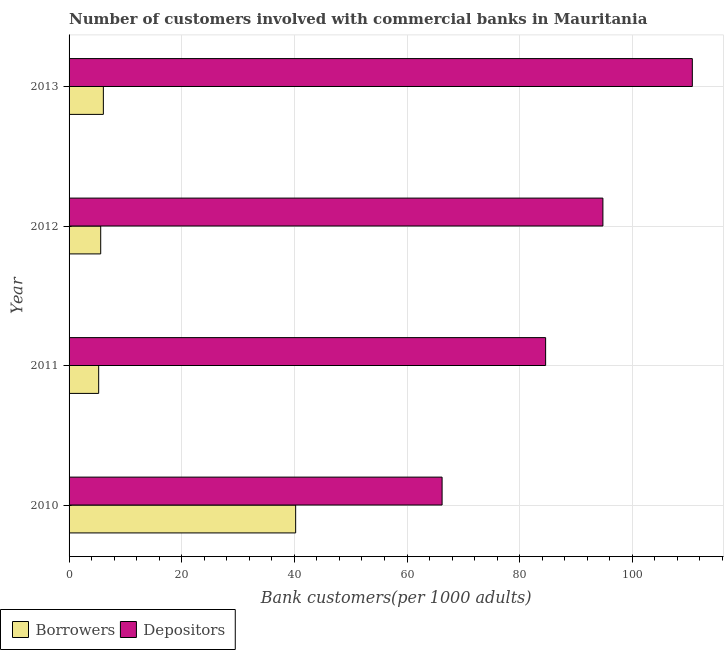Are the number of bars per tick equal to the number of legend labels?
Your answer should be very brief. Yes. Are the number of bars on each tick of the Y-axis equal?
Give a very brief answer. Yes. How many bars are there on the 4th tick from the top?
Make the answer very short. 2. What is the number of depositors in 2011?
Your answer should be compact. 84.61. Across all years, what is the maximum number of borrowers?
Provide a short and direct response. 40.23. Across all years, what is the minimum number of borrowers?
Make the answer very short. 5.26. What is the total number of borrowers in the graph?
Keep it short and to the point. 57.19. What is the difference between the number of depositors in 2012 and that in 2013?
Provide a succinct answer. -15.88. What is the difference between the number of borrowers in 2012 and the number of depositors in 2013?
Offer a very short reply. -105.04. What is the average number of depositors per year?
Give a very brief answer. 89.07. In the year 2012, what is the difference between the number of depositors and number of borrowers?
Your response must be concise. 89.16. What is the ratio of the number of depositors in 2010 to that in 2012?
Your answer should be compact. 0.7. Is the number of depositors in 2010 less than that in 2012?
Provide a short and direct response. Yes. Is the difference between the number of depositors in 2011 and 2012 greater than the difference between the number of borrowers in 2011 and 2012?
Ensure brevity in your answer.  No. What is the difference between the highest and the second highest number of depositors?
Your response must be concise. 15.88. What is the difference between the highest and the lowest number of depositors?
Keep it short and to the point. 44.43. What does the 2nd bar from the top in 2013 represents?
Make the answer very short. Borrowers. What does the 2nd bar from the bottom in 2010 represents?
Offer a terse response. Depositors. How many bars are there?
Your response must be concise. 8. Are all the bars in the graph horizontal?
Make the answer very short. Yes. Does the graph contain grids?
Ensure brevity in your answer.  Yes. Where does the legend appear in the graph?
Keep it short and to the point. Bottom left. What is the title of the graph?
Your response must be concise. Number of customers involved with commercial banks in Mauritania. What is the label or title of the X-axis?
Offer a terse response. Bank customers(per 1000 adults). What is the Bank customers(per 1000 adults) in Borrowers in 2010?
Provide a short and direct response. 40.23. What is the Bank customers(per 1000 adults) in Depositors in 2010?
Make the answer very short. 66.23. What is the Bank customers(per 1000 adults) of Borrowers in 2011?
Make the answer very short. 5.26. What is the Bank customers(per 1000 adults) of Depositors in 2011?
Provide a short and direct response. 84.61. What is the Bank customers(per 1000 adults) of Borrowers in 2012?
Offer a very short reply. 5.62. What is the Bank customers(per 1000 adults) in Depositors in 2012?
Give a very brief answer. 94.78. What is the Bank customers(per 1000 adults) of Borrowers in 2013?
Provide a succinct answer. 6.09. What is the Bank customers(per 1000 adults) in Depositors in 2013?
Your answer should be compact. 110.66. Across all years, what is the maximum Bank customers(per 1000 adults) in Borrowers?
Your response must be concise. 40.23. Across all years, what is the maximum Bank customers(per 1000 adults) in Depositors?
Keep it short and to the point. 110.66. Across all years, what is the minimum Bank customers(per 1000 adults) of Borrowers?
Provide a short and direct response. 5.26. Across all years, what is the minimum Bank customers(per 1000 adults) in Depositors?
Keep it short and to the point. 66.23. What is the total Bank customers(per 1000 adults) of Borrowers in the graph?
Offer a terse response. 57.19. What is the total Bank customers(per 1000 adults) of Depositors in the graph?
Keep it short and to the point. 356.28. What is the difference between the Bank customers(per 1000 adults) of Borrowers in 2010 and that in 2011?
Your response must be concise. 34.97. What is the difference between the Bank customers(per 1000 adults) of Depositors in 2010 and that in 2011?
Make the answer very short. -18.38. What is the difference between the Bank customers(per 1000 adults) in Borrowers in 2010 and that in 2012?
Provide a succinct answer. 34.61. What is the difference between the Bank customers(per 1000 adults) of Depositors in 2010 and that in 2012?
Provide a short and direct response. -28.55. What is the difference between the Bank customers(per 1000 adults) in Borrowers in 2010 and that in 2013?
Your answer should be compact. 34.14. What is the difference between the Bank customers(per 1000 adults) of Depositors in 2010 and that in 2013?
Your answer should be compact. -44.43. What is the difference between the Bank customers(per 1000 adults) of Borrowers in 2011 and that in 2012?
Ensure brevity in your answer.  -0.36. What is the difference between the Bank customers(per 1000 adults) of Depositors in 2011 and that in 2012?
Keep it short and to the point. -10.17. What is the difference between the Bank customers(per 1000 adults) of Borrowers in 2011 and that in 2013?
Your answer should be compact. -0.83. What is the difference between the Bank customers(per 1000 adults) of Depositors in 2011 and that in 2013?
Ensure brevity in your answer.  -26.05. What is the difference between the Bank customers(per 1000 adults) in Borrowers in 2012 and that in 2013?
Ensure brevity in your answer.  -0.47. What is the difference between the Bank customers(per 1000 adults) of Depositors in 2012 and that in 2013?
Offer a terse response. -15.88. What is the difference between the Bank customers(per 1000 adults) in Borrowers in 2010 and the Bank customers(per 1000 adults) in Depositors in 2011?
Make the answer very short. -44.38. What is the difference between the Bank customers(per 1000 adults) in Borrowers in 2010 and the Bank customers(per 1000 adults) in Depositors in 2012?
Provide a succinct answer. -54.55. What is the difference between the Bank customers(per 1000 adults) of Borrowers in 2010 and the Bank customers(per 1000 adults) of Depositors in 2013?
Offer a very short reply. -70.43. What is the difference between the Bank customers(per 1000 adults) in Borrowers in 2011 and the Bank customers(per 1000 adults) in Depositors in 2012?
Keep it short and to the point. -89.52. What is the difference between the Bank customers(per 1000 adults) in Borrowers in 2011 and the Bank customers(per 1000 adults) in Depositors in 2013?
Offer a very short reply. -105.4. What is the difference between the Bank customers(per 1000 adults) of Borrowers in 2012 and the Bank customers(per 1000 adults) of Depositors in 2013?
Provide a succinct answer. -105.04. What is the average Bank customers(per 1000 adults) in Borrowers per year?
Your answer should be compact. 14.3. What is the average Bank customers(per 1000 adults) in Depositors per year?
Ensure brevity in your answer.  89.07. In the year 2010, what is the difference between the Bank customers(per 1000 adults) in Borrowers and Bank customers(per 1000 adults) in Depositors?
Offer a terse response. -26. In the year 2011, what is the difference between the Bank customers(per 1000 adults) of Borrowers and Bank customers(per 1000 adults) of Depositors?
Ensure brevity in your answer.  -79.36. In the year 2012, what is the difference between the Bank customers(per 1000 adults) of Borrowers and Bank customers(per 1000 adults) of Depositors?
Your answer should be compact. -89.16. In the year 2013, what is the difference between the Bank customers(per 1000 adults) in Borrowers and Bank customers(per 1000 adults) in Depositors?
Give a very brief answer. -104.57. What is the ratio of the Bank customers(per 1000 adults) of Borrowers in 2010 to that in 2011?
Provide a succinct answer. 7.65. What is the ratio of the Bank customers(per 1000 adults) in Depositors in 2010 to that in 2011?
Give a very brief answer. 0.78. What is the ratio of the Bank customers(per 1000 adults) of Borrowers in 2010 to that in 2012?
Your answer should be compact. 7.16. What is the ratio of the Bank customers(per 1000 adults) of Depositors in 2010 to that in 2012?
Offer a very short reply. 0.7. What is the ratio of the Bank customers(per 1000 adults) in Borrowers in 2010 to that in 2013?
Provide a short and direct response. 6.61. What is the ratio of the Bank customers(per 1000 adults) of Depositors in 2010 to that in 2013?
Give a very brief answer. 0.6. What is the ratio of the Bank customers(per 1000 adults) in Borrowers in 2011 to that in 2012?
Ensure brevity in your answer.  0.94. What is the ratio of the Bank customers(per 1000 adults) of Depositors in 2011 to that in 2012?
Make the answer very short. 0.89. What is the ratio of the Bank customers(per 1000 adults) in Borrowers in 2011 to that in 2013?
Your answer should be very brief. 0.86. What is the ratio of the Bank customers(per 1000 adults) of Depositors in 2011 to that in 2013?
Keep it short and to the point. 0.76. What is the ratio of the Bank customers(per 1000 adults) in Borrowers in 2012 to that in 2013?
Your answer should be very brief. 0.92. What is the ratio of the Bank customers(per 1000 adults) of Depositors in 2012 to that in 2013?
Offer a terse response. 0.86. What is the difference between the highest and the second highest Bank customers(per 1000 adults) in Borrowers?
Provide a short and direct response. 34.14. What is the difference between the highest and the second highest Bank customers(per 1000 adults) in Depositors?
Your answer should be compact. 15.88. What is the difference between the highest and the lowest Bank customers(per 1000 adults) of Borrowers?
Make the answer very short. 34.97. What is the difference between the highest and the lowest Bank customers(per 1000 adults) in Depositors?
Give a very brief answer. 44.43. 